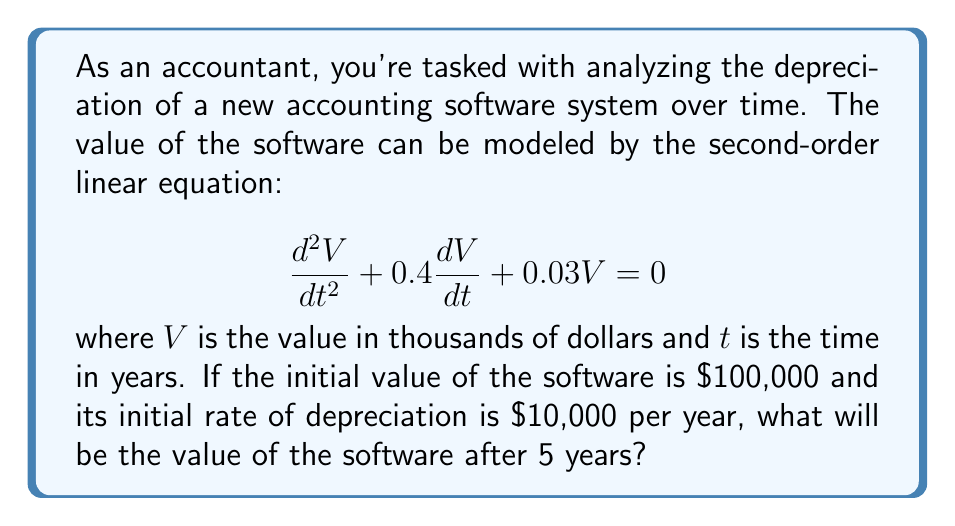Can you solve this math problem? To solve this problem, we need to follow these steps:

1) First, we need to find the general solution of the given differential equation. The characteristic equation is:

   $$r^2 + 0.4r + 0.03 = 0$$

2) Solving this quadratic equation:
   
   $$r = \frac{-0.4 \pm \sqrt{0.4^2 - 4(0.03)}}{2} = \frac{-0.4 \pm \sqrt{0.04}}{2} = \frac{-0.4 \pm 0.2}{2}$$

3) This gives us two roots: $r_1 = -0.3$ and $r_2 = -0.1$

4) Therefore, the general solution is:

   $$V(t) = C_1e^{-0.3t} + C_2e^{-0.1t}$$

5) Now we use the initial conditions to find $C_1$ and $C_2$:
   
   At $t=0$, $V(0) = 100$ (as the initial value is $\$100,000$)
   
   $$100 = C_1 + C_2$$

   Also, $V'(0) = -10$ (as the initial depreciation rate is $\$10,000$ per year)
   
   $$-10 = -0.3C_1 - 0.1C_2$$

6) Solving these simultaneous equations:

   $$C_1 = 40 \text{ and } C_2 = 60$$

7) Therefore, the particular solution is:

   $$V(t) = 40e^{-0.3t} + 60e^{-0.1t}$$

8) To find the value after 5 years, we substitute $t=5$:

   $$V(5) = 40e^{-0.3(5)} + 60e^{-0.1(5)} = 40e^{-1.5} + 60e^{-0.5}$$

9) Calculating this:

   $$V(5) \approx 40(0.2231) + 60(0.6065) \approx 8.924 + 36.39 \approx 45.314$$

Therefore, after 5 years, the software will be worth approximately $\$45,314$.
Answer: $\$45,314$ 